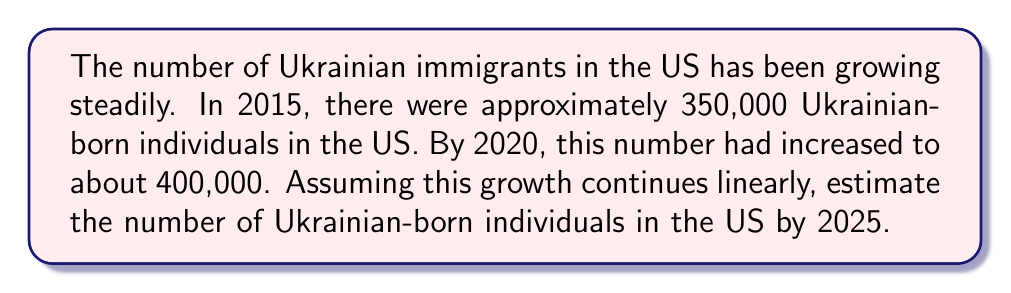Can you answer this question? To solve this problem, we'll use a linear equation to model the growth of the Ukrainian immigrant population in the US.

Step 1: Identify the given information
- In 2015: 350,000 Ukrainian-born individuals
- In 2020: 400,000 Ukrainian-born individuals
- Time span: 5 years

Step 2: Calculate the rate of growth per year
Rate of growth = (End value - Start value) / Time span
$$ \text{Rate} = \frac{400,000 - 350,000}{5} = \frac{50,000}{5} = 10,000 \text{ per year} $$

Step 3: Set up a linear equation
Let $y$ be the number of Ukrainian-born individuals and $x$ be the number of years since 2015.
$$ y = 350,000 + 10,000x $$

Step 4: Calculate the number of years from 2015 to 2025
2025 - 2015 = 10 years

Step 5: Substitute $x = 10$ into the equation
$$ y = 350,000 + 10,000(10) = 350,000 + 100,000 = 450,000 $$

Therefore, by 2025, we estimate there will be 450,000 Ukrainian-born individuals in the US.
Answer: 450,000 Ukrainian-born individuals 